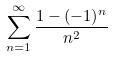<formula> <loc_0><loc_0><loc_500><loc_500>\sum _ { n = 1 } ^ { \infty } \frac { 1 - ( - 1 ) ^ { n } } { n ^ { 2 } }</formula> 